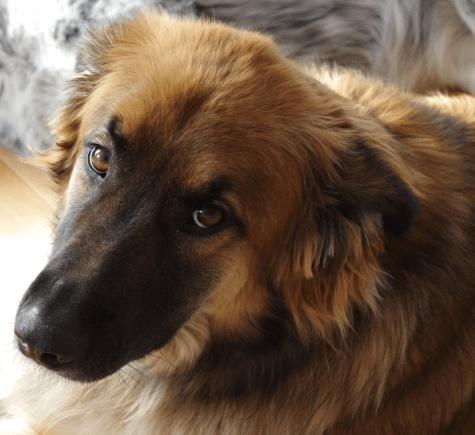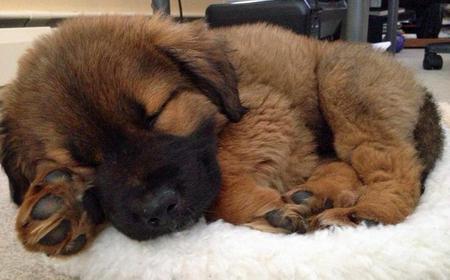The first image is the image on the left, the second image is the image on the right. Given the left and right images, does the statement "A dog's pink tongue is visible in one image." hold true? Answer yes or no. No. The first image is the image on the left, the second image is the image on the right. Analyze the images presented: Is the assertion "There is a single brown dog sleeping alone in the image on the right." valid? Answer yes or no. Yes. 